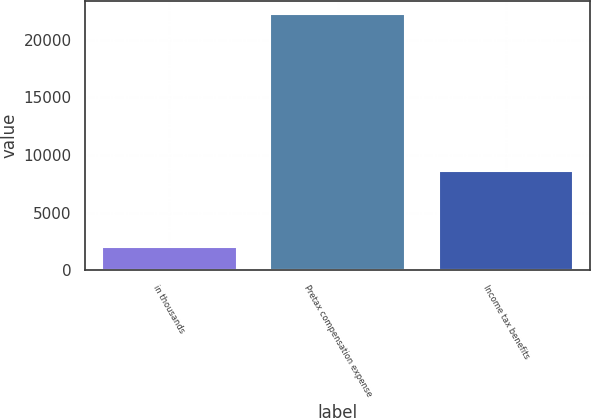<chart> <loc_0><loc_0><loc_500><loc_500><bar_chart><fcel>in thousands<fcel>Pretax compensation expense<fcel>Income tax benefits<nl><fcel>2014<fcel>22217<fcel>8571<nl></chart> 